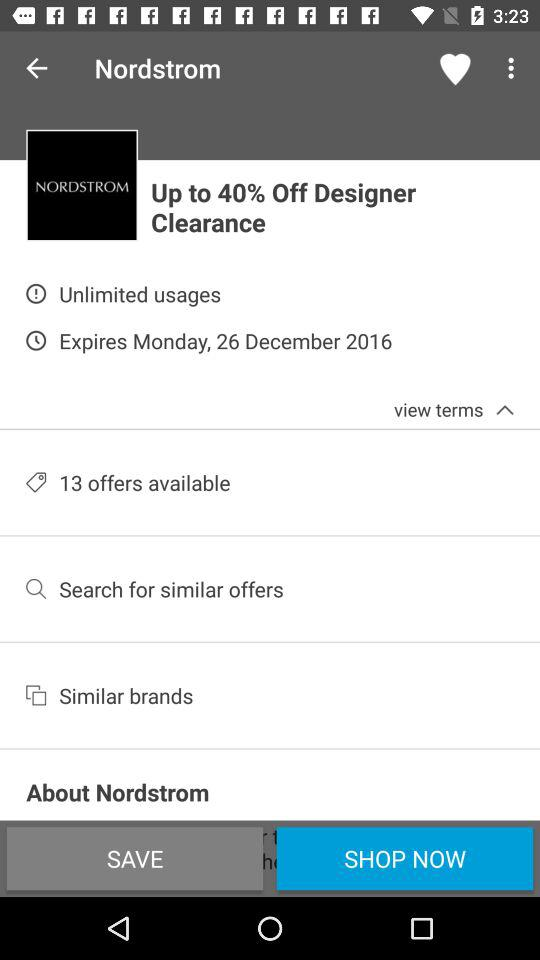What is the expiration date? The expiration date is Monday, December 26, 2016. 